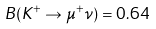Convert formula to latex. <formula><loc_0><loc_0><loc_500><loc_500>B ( K ^ { + } \to \mu ^ { + } \nu ) = 0 . 6 4</formula> 